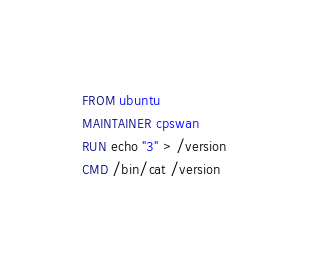<code> <loc_0><loc_0><loc_500><loc_500><_Dockerfile_>FROM ubuntu
MAINTAINER cpswan
RUN echo "3" > /version
CMD /bin/cat /version
</code> 